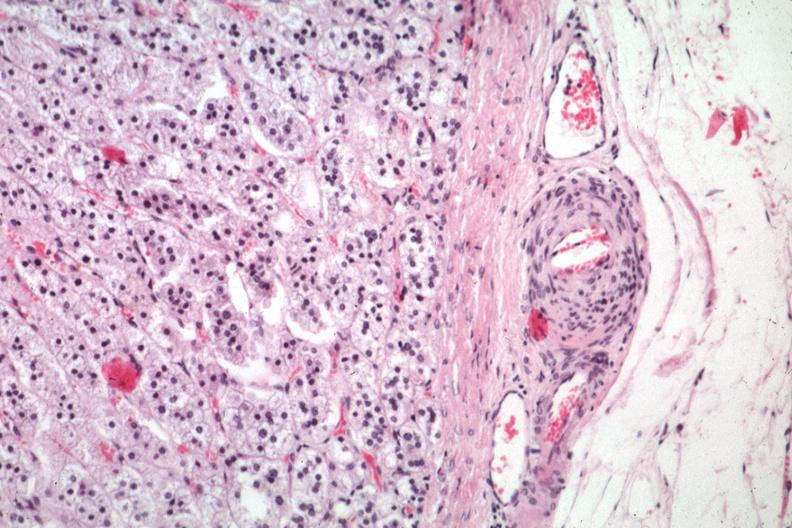what does this image show?
Answer the question using a single word or phrase. Typical lesion in small artery just outside capsule 